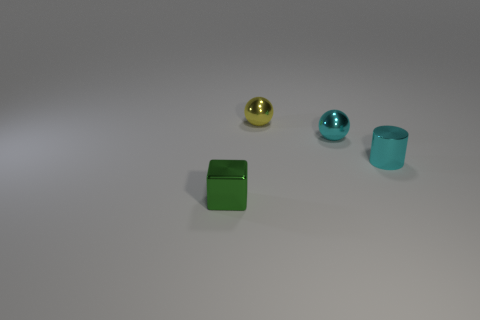There is a cyan object behind the cyan cylinder; does it have the same shape as the thing behind the small cyan ball?
Provide a succinct answer. Yes. Is there any other thing that is the same shape as the small yellow metal thing?
Keep it short and to the point. Yes. The yellow object that is made of the same material as the tiny cyan cylinder is what shape?
Offer a terse response. Sphere. Are there the same number of small cyan metallic cylinders in front of the small green shiny thing and large red cylinders?
Give a very brief answer. Yes. Is the material of the small sphere that is to the left of the cyan metal ball the same as the cyan thing in front of the small cyan ball?
Your response must be concise. Yes. There is a small cyan object that is in front of the tiny cyan metal thing that is behind the small cyan cylinder; what is its shape?
Provide a short and direct response. Cylinder. What color is the other small ball that is made of the same material as the tiny cyan ball?
Your answer should be very brief. Yellow. What is the shape of the cyan object that is the same size as the metal cylinder?
Provide a succinct answer. Sphere. There is a small metal object in front of the tiny thing that is right of the small cyan ball; what color is it?
Offer a very short reply. Green. What number of metal things are yellow cubes or cyan cylinders?
Offer a terse response. 1. 